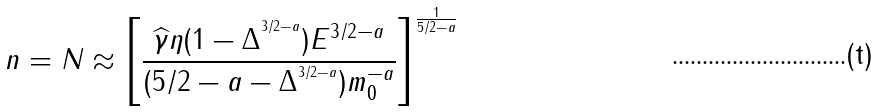Convert formula to latex. <formula><loc_0><loc_0><loc_500><loc_500>n = N \approx \left [ \frac { \widehat { \gamma } \eta ( 1 - \Delta ^ { ^ { 3 / 2 - a } } ) E ^ { 3 / 2 - a } } { ( 5 / 2 - a - \Delta ^ { ^ { 3 / 2 - a } } ) m _ { 0 } ^ { - a } } \right ] ^ { \frac { 1 } { 5 / 2 - a } }</formula> 